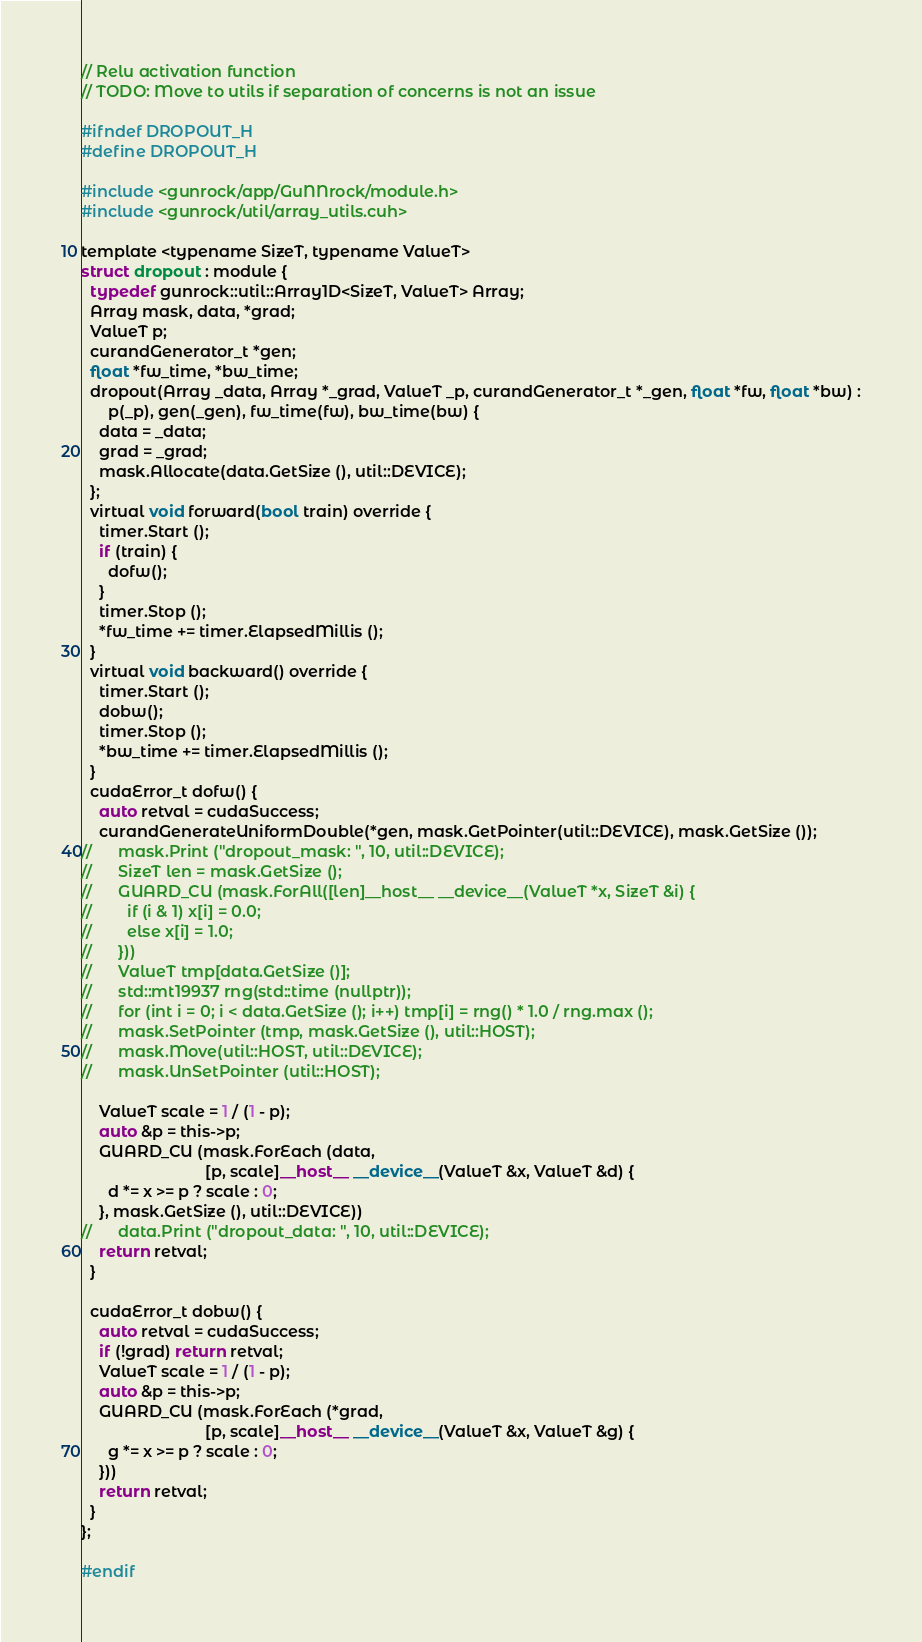Convert code to text. <code><loc_0><loc_0><loc_500><loc_500><_Cuda_>// Relu activation function
// TODO: Move to utils if separation of concerns is not an issue

#ifndef DROPOUT_H
#define DROPOUT_H

#include <gunrock/app/GuNNrock/module.h>
#include <gunrock/util/array_utils.cuh>

template <typename SizeT, typename ValueT>
struct dropout : module {
  typedef gunrock::util::Array1D<SizeT, ValueT> Array;
  Array mask, data, *grad;
  ValueT p;
  curandGenerator_t *gen;
  float *fw_time, *bw_time;
  dropout(Array _data, Array *_grad, ValueT _p, curandGenerator_t *_gen, float *fw, float *bw) :
      p(_p), gen(_gen), fw_time(fw), bw_time(bw) {
    data = _data;
    grad = _grad;
    mask.Allocate(data.GetSize (), util::DEVICE);
  };
  virtual void forward(bool train) override {
    timer.Start ();
    if (train) {
      dofw();
    }
    timer.Stop ();
    *fw_time += timer.ElapsedMillis ();
  }
  virtual void backward() override {
    timer.Start ();
    dobw();
    timer.Stop ();
    *bw_time += timer.ElapsedMillis ();
  }
  cudaError_t dofw() {
    auto retval = cudaSuccess;
    curandGenerateUniformDouble(*gen, mask.GetPointer(util::DEVICE), mask.GetSize ());
//      mask.Print ("dropout_mask: ", 10, util::DEVICE);
//      SizeT len = mask.GetSize ();
//      GUARD_CU (mask.ForAll([len]__host__ __device__(ValueT *x, SizeT &i) {
//        if (i & 1) x[i] = 0.0;
//        else x[i] = 1.0;
//      }))
//      ValueT tmp[data.GetSize ()];
//      std::mt19937 rng(std::time (nullptr));
//      for (int i = 0; i < data.GetSize (); i++) tmp[i] = rng() * 1.0 / rng.max ();
//      mask.SetPointer (tmp, mask.GetSize (), util::HOST);
//      mask.Move(util::HOST, util::DEVICE);
//      mask.UnSetPointer (util::HOST);

    ValueT scale = 1 / (1 - p);
    auto &p = this->p;
    GUARD_CU (mask.ForEach (data,
                            [p, scale]__host__ __device__(ValueT &x, ValueT &d) {
      d *= x >= p ? scale : 0;
    }, mask.GetSize (), util::DEVICE))
//      data.Print ("dropout_data: ", 10, util::DEVICE);
    return retval;
  }

  cudaError_t dobw() {
    auto retval = cudaSuccess;
    if (!grad) return retval;
    ValueT scale = 1 / (1 - p);
    auto &p = this->p;
    GUARD_CU (mask.ForEach (*grad,
                            [p, scale]__host__ __device__(ValueT &x, ValueT &g) {
      g *= x >= p ? scale : 0;
    }))
    return retval;
  }
};

#endif</code> 